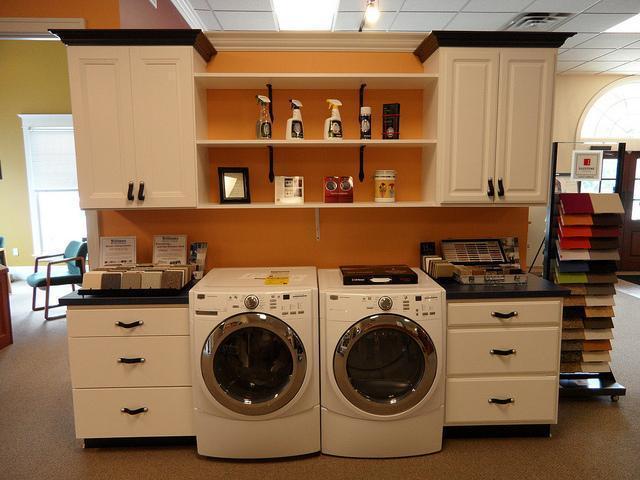How many people are sitting down on chairs?
Give a very brief answer. 0. 